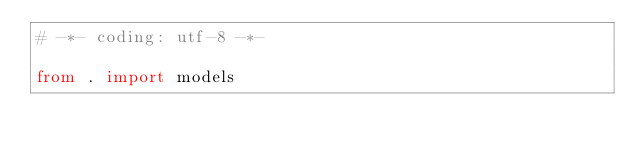Convert code to text. <code><loc_0><loc_0><loc_500><loc_500><_Python_># -*- coding: utf-8 -*-

from . import models
</code> 